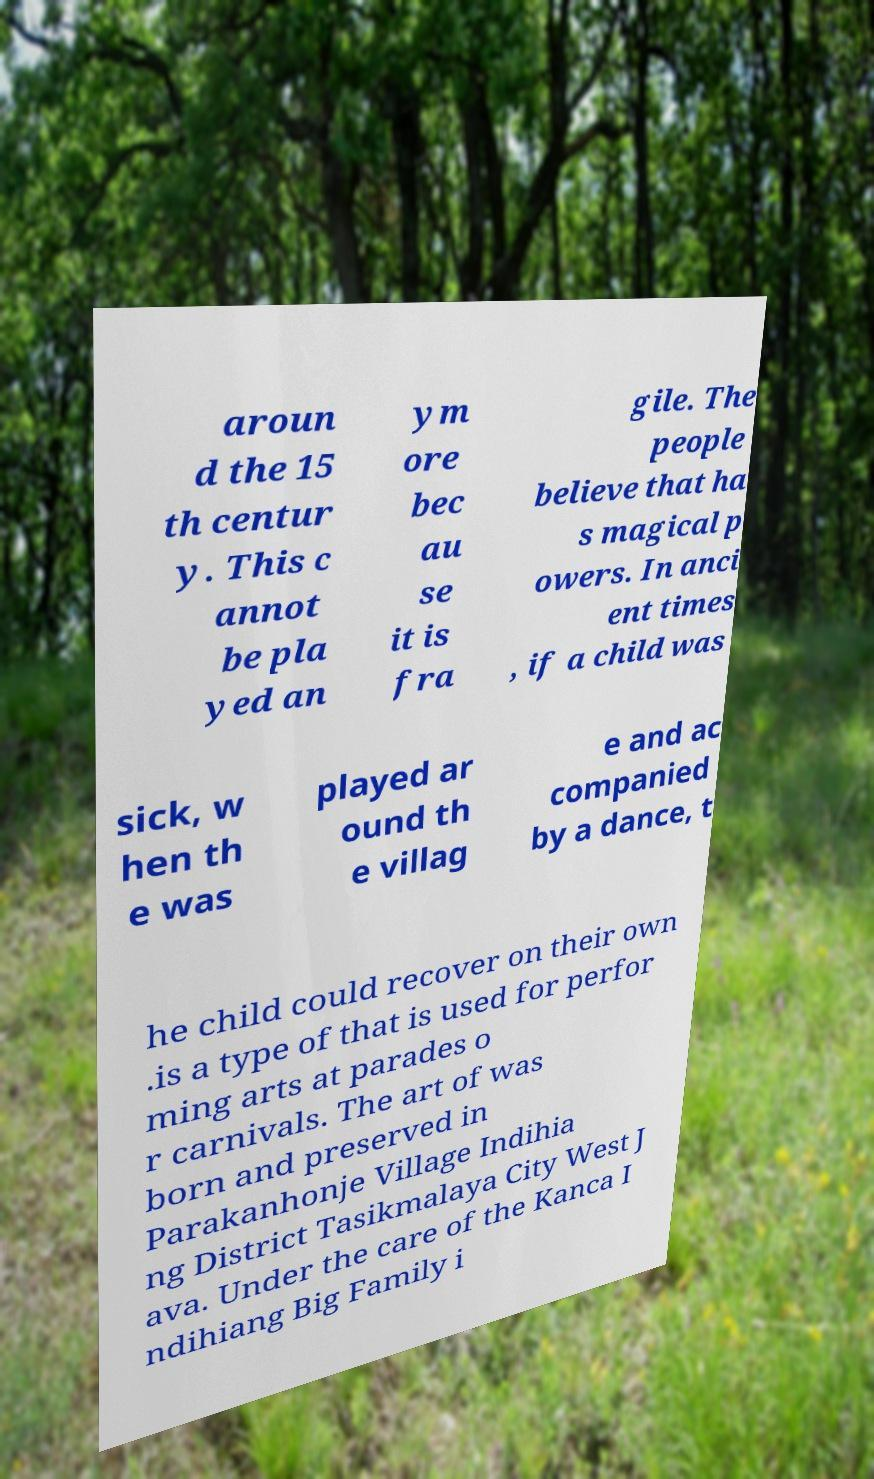For documentation purposes, I need the text within this image transcribed. Could you provide that? aroun d the 15 th centur y. This c annot be pla yed an ym ore bec au se it is fra gile. The people believe that ha s magical p owers. In anci ent times , if a child was sick, w hen th e was played ar ound th e villag e and ac companied by a dance, t he child could recover on their own .is a type of that is used for perfor ming arts at parades o r carnivals. The art of was born and preserved in Parakanhonje Village Indihia ng District Tasikmalaya City West J ava. Under the care of the Kanca I ndihiang Big Family i 